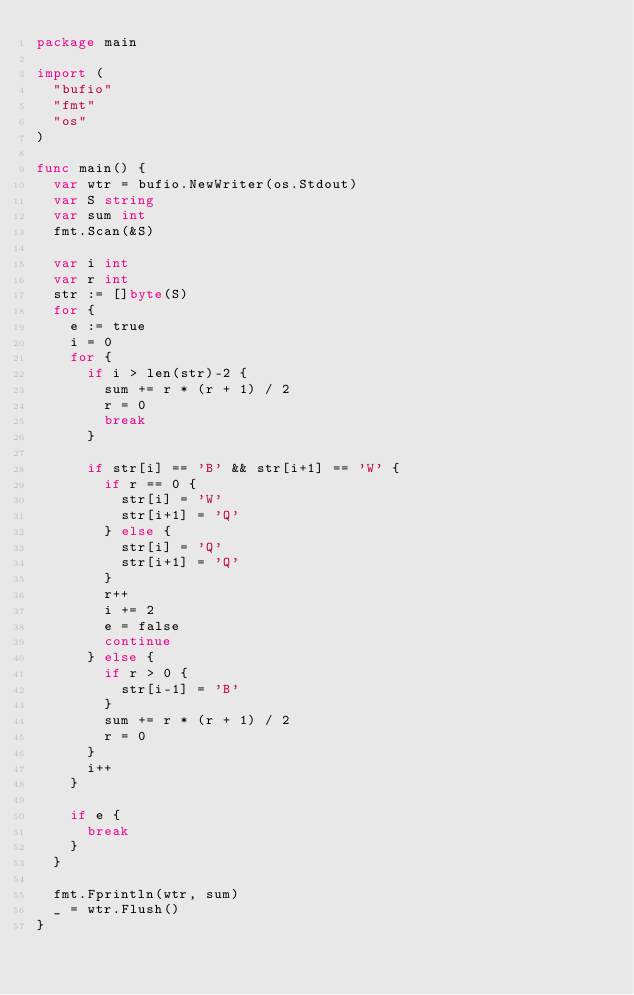<code> <loc_0><loc_0><loc_500><loc_500><_Go_>package main

import (
	"bufio"
	"fmt"
	"os"
)

func main() {
	var wtr = bufio.NewWriter(os.Stdout)
	var S string
	var sum int
	fmt.Scan(&S)

	var i int
	var r int
	str := []byte(S)
	for {
		e := true
		i = 0
		for {
			if i > len(str)-2 {
				sum += r * (r + 1) / 2
				r = 0
				break
			}

			if str[i] == 'B' && str[i+1] == 'W' {
				if r == 0 {
					str[i] = 'W'
					str[i+1] = 'Q'
				} else {
					str[i] = 'Q'
					str[i+1] = 'Q'
				}
				r++
				i += 2
				e = false
				continue
			} else {
				if r > 0 {
					str[i-1] = 'B'
				}
				sum += r * (r + 1) / 2
				r = 0
			}
			i++
		}

		if e {
			break
		}
	}

	fmt.Fprintln(wtr, sum)
	_ = wtr.Flush()
}
</code> 